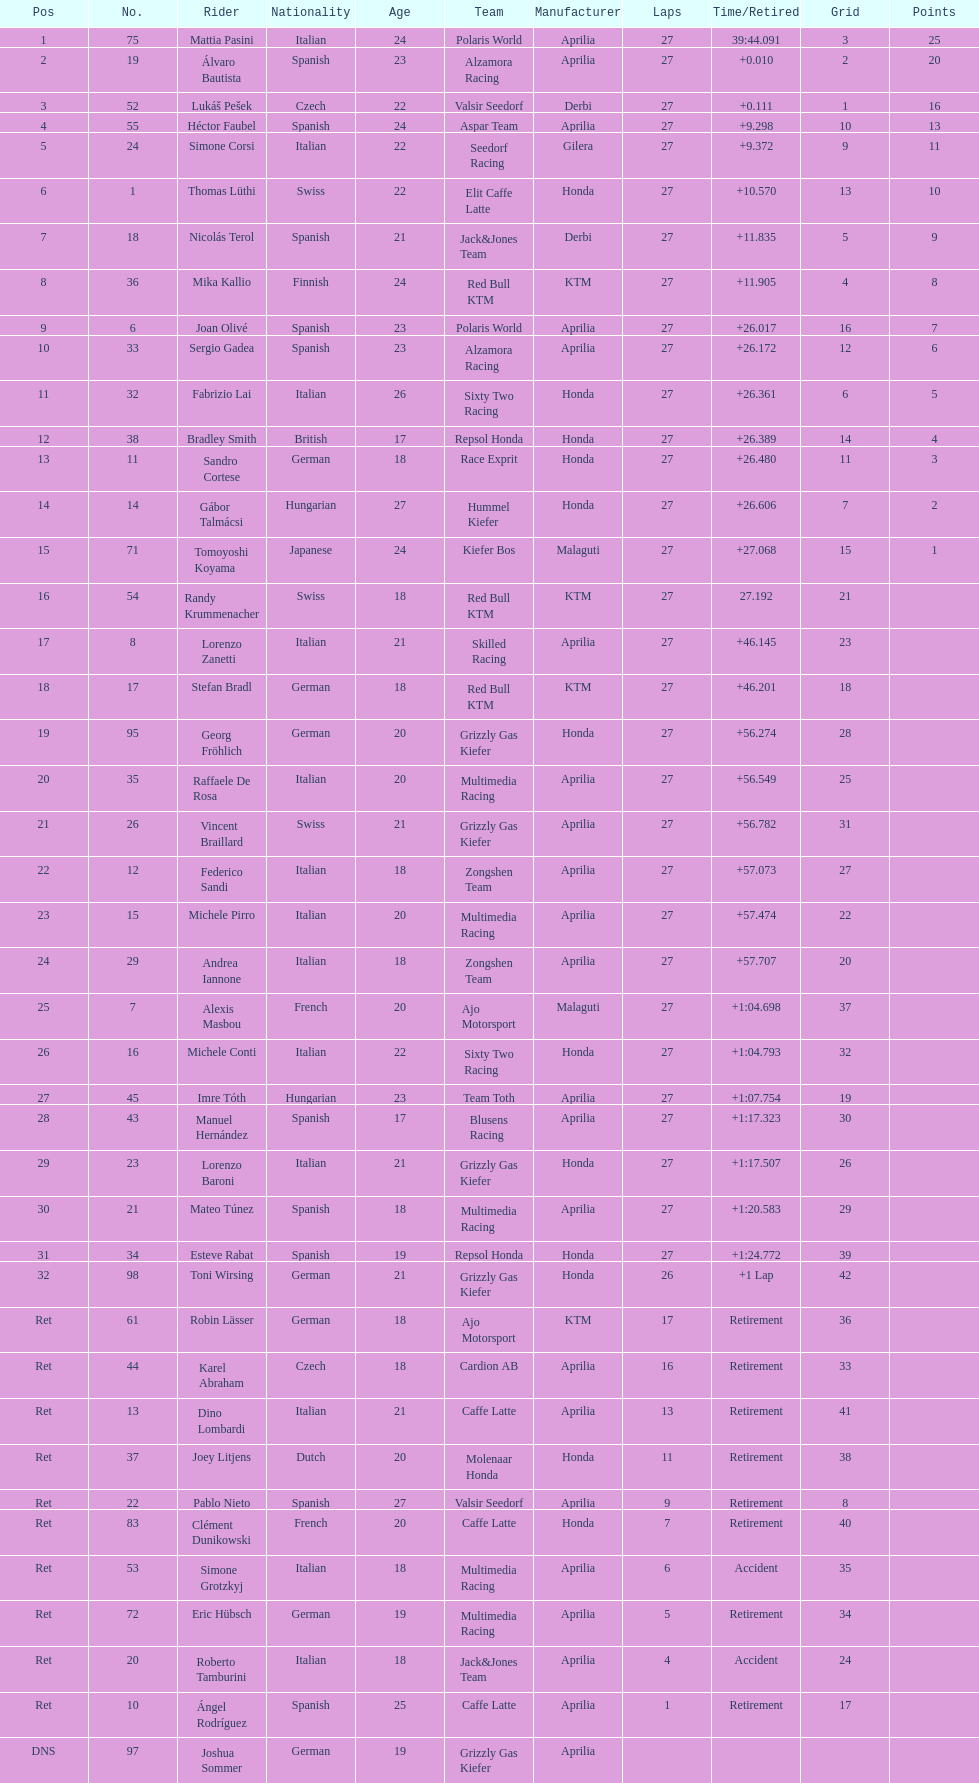How many german racers finished the race? 4. 